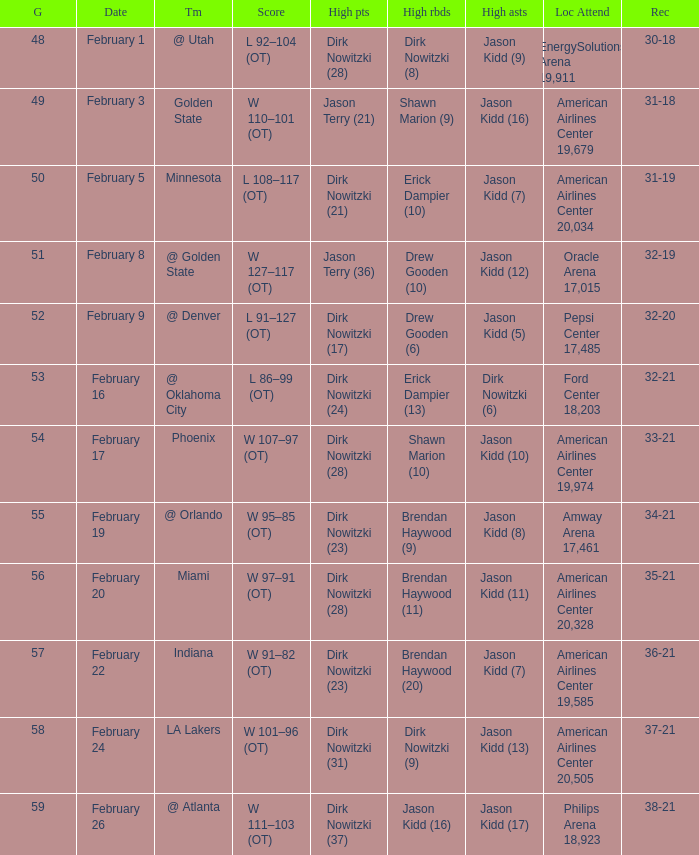Who had the most high assists with a record of 32-19? Jason Kidd (12). 